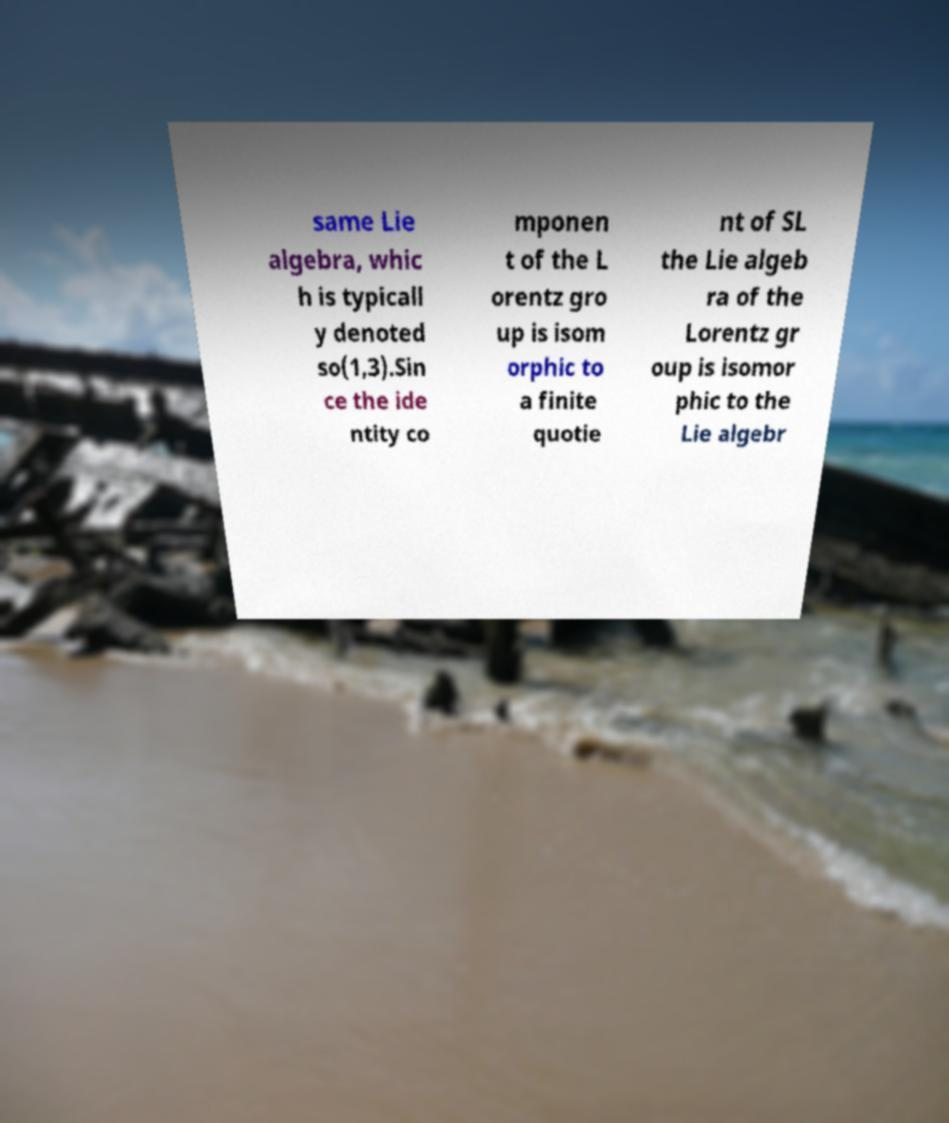There's text embedded in this image that I need extracted. Can you transcribe it verbatim? same Lie algebra, whic h is typicall y denoted so(1,3).Sin ce the ide ntity co mponen t of the L orentz gro up is isom orphic to a finite quotie nt of SL the Lie algeb ra of the Lorentz gr oup is isomor phic to the Lie algebr 